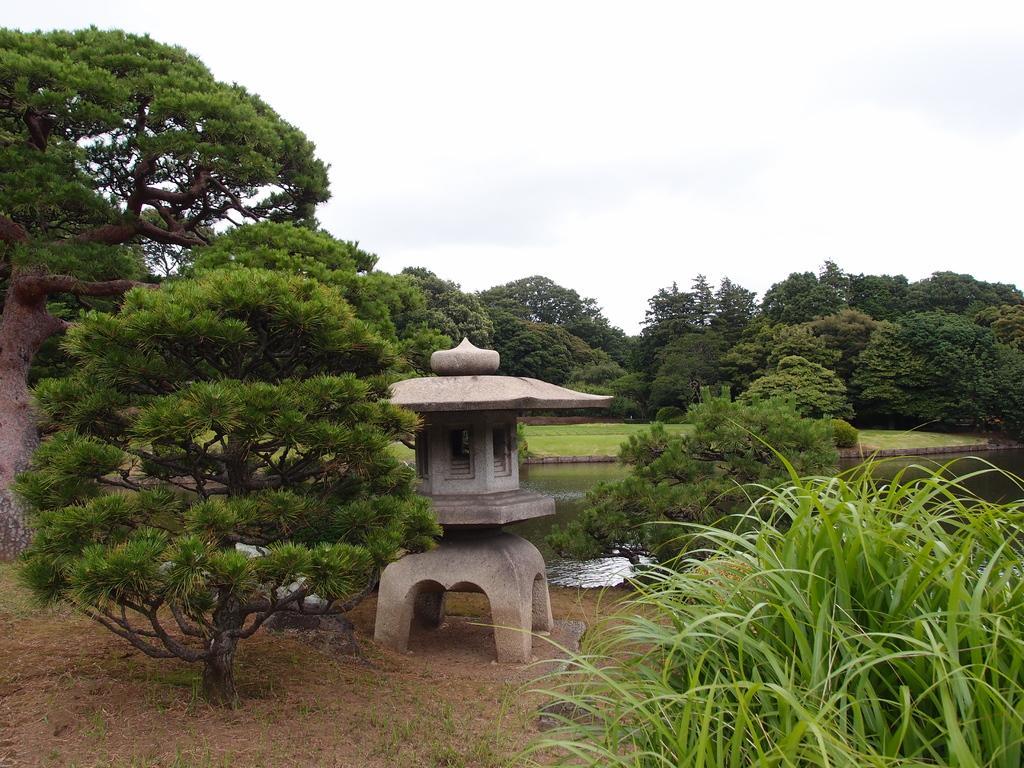Describe this image in one or two sentences. In this picture I can see trees and plants and I can see water and a small house like structure in the middle of the picture and I can see a cloudy sky. 